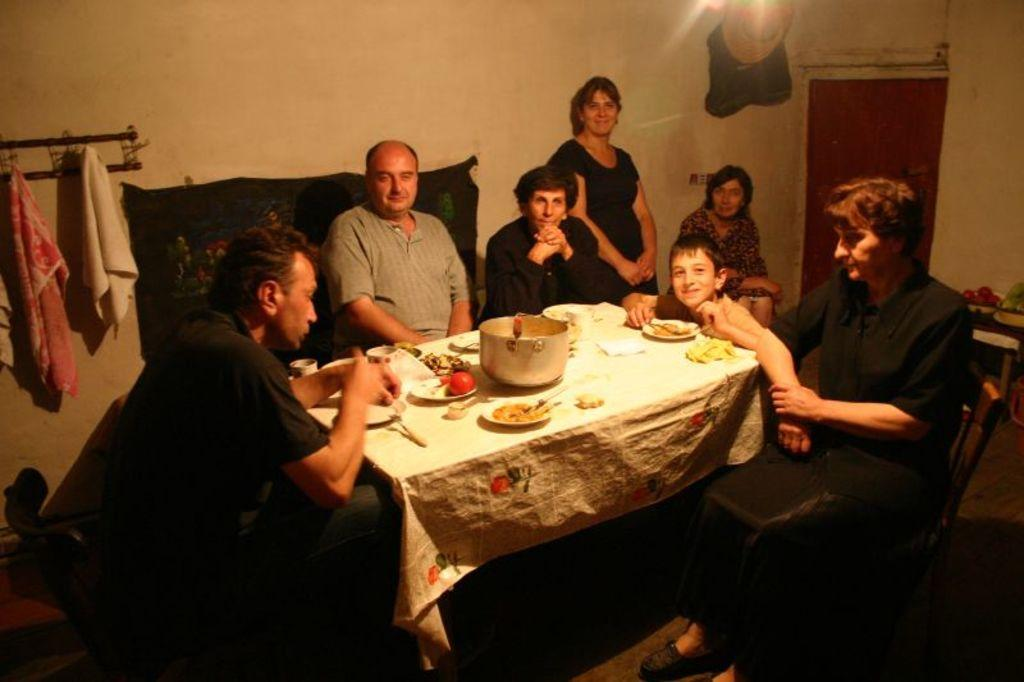How many people are present in the image? There are seven people in the image. What are the people doing in the image? The people are sitting around a table. What can be seen on the table in the image? There are food items placed on the table. What type of knowledge can be gained from the shoes in the image? There are no shoes present in the image, so no knowledge can be gained from them. 